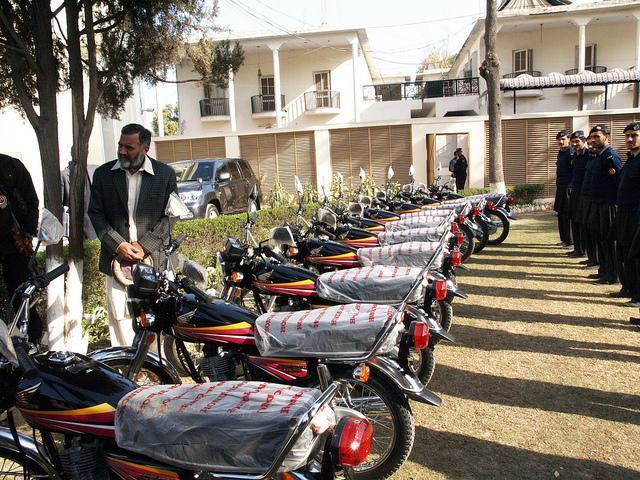How many people are there?
Give a very brief answer. 4. How many motorcycles are in the photo?
Give a very brief answer. 5. How many trucks are parked on the road?
Give a very brief answer. 0. 